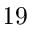<formula> <loc_0><loc_0><loc_500><loc_500>1 9</formula> 